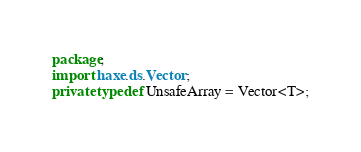<code> <loc_0><loc_0><loc_500><loc_500><_Haxe_>package;
import haxe.ds.Vector;
private typedef UnsafeArray = Vector<T>;</code> 